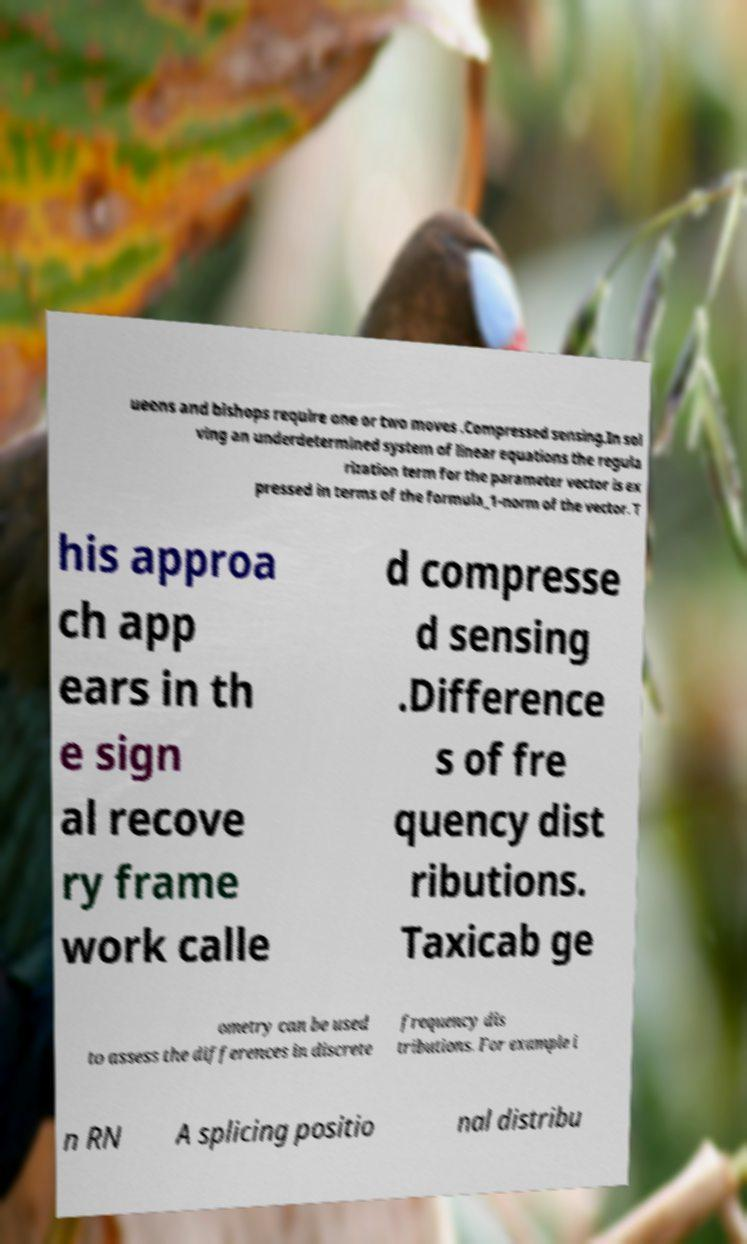There's text embedded in this image that I need extracted. Can you transcribe it verbatim? ueens and bishops require one or two moves .Compressed sensing.In sol ving an underdetermined system of linear equations the regula rization term for the parameter vector is ex pressed in terms of the formula_1-norm of the vector. T his approa ch app ears in th e sign al recove ry frame work calle d compresse d sensing .Difference s of fre quency dist ributions. Taxicab ge ometry can be used to assess the differences in discrete frequency dis tributions. For example i n RN A splicing positio nal distribu 